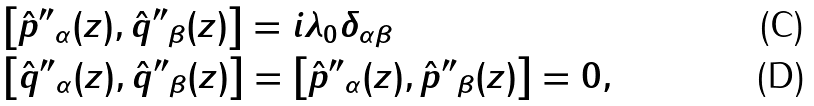<formula> <loc_0><loc_0><loc_500><loc_500>& \left [ \hat { p } { ^ { \prime \prime } } _ { \alpha } ( z ) , \hat { q } { ^ { \prime \prime } } _ { \beta } ( z ) \right ] = i \lambda _ { 0 } \delta _ { { \alpha } \beta } \\ & \left [ \hat { q } { ^ { \prime \prime } } _ { \alpha } ( z ) , \hat { q } { ^ { \prime \prime } } _ { \beta } ( z ) \right ] = \left [ \hat { p } { ^ { \prime \prime } } _ { \alpha } ( z ) , \hat { p } { ^ { \prime \prime } } _ { \beta } ( z ) \right ] = 0 ,</formula> 